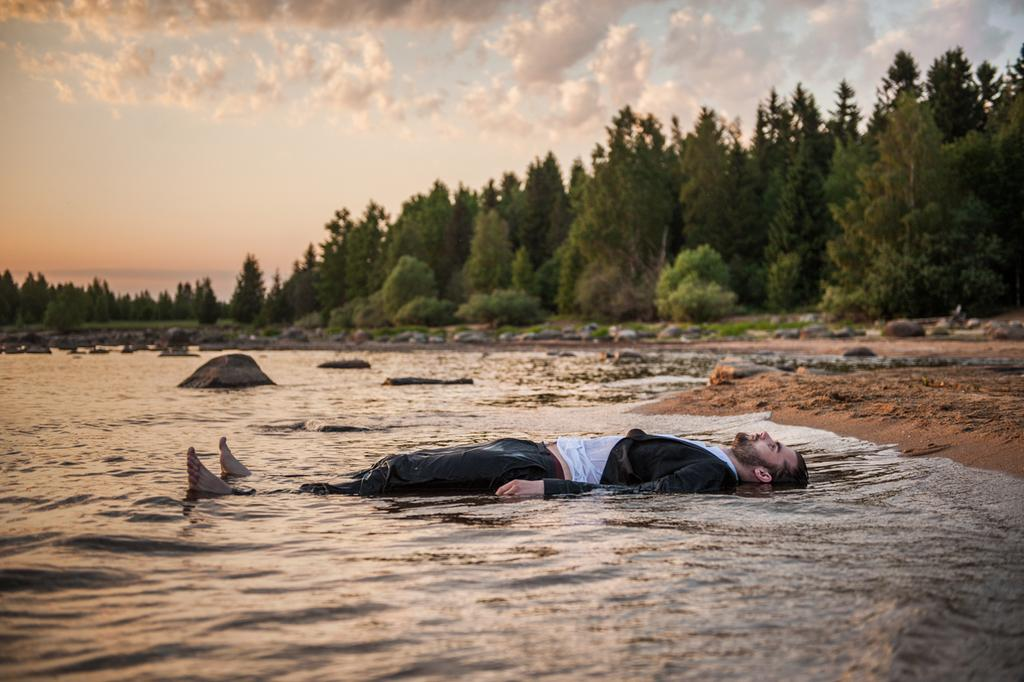What is the man in the image doing near the water? The man is lying on the water near the shore. What type of vegetation can be seen in the image? There are many trees in the image. What is the ground made of in the image? Sand is present in the image. What other natural features can be seen in the image? Rocks are visible in the image. How would you describe the weather based on the image? The sky is cloudy in the image. What type of toothpaste is the man using while lying on the water? There is no toothpaste present in the image, and the man is not using any toothpaste. Can you hear a whistle in the image? There is no whistle present in the image, and no sound can be heard from the image. 